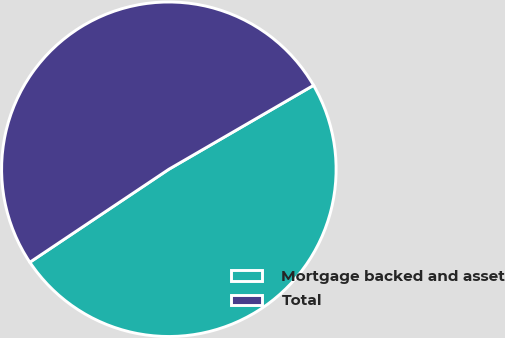Convert chart. <chart><loc_0><loc_0><loc_500><loc_500><pie_chart><fcel>Mortgage backed and asset<fcel>Total<nl><fcel>48.98%<fcel>51.02%<nl></chart> 